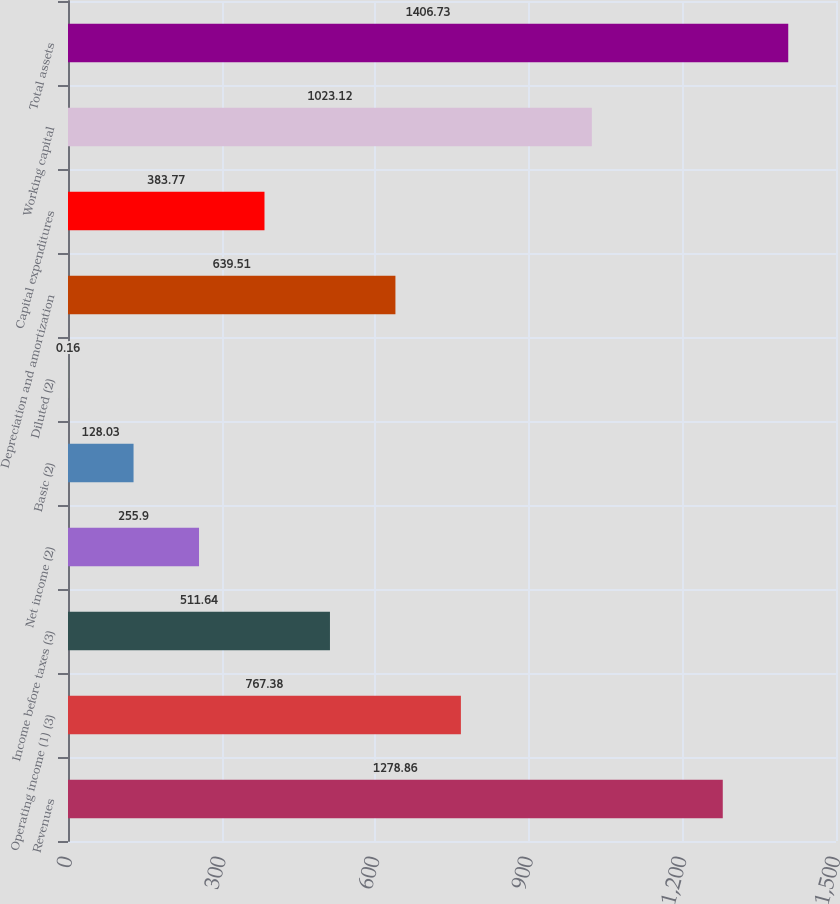Convert chart to OTSL. <chart><loc_0><loc_0><loc_500><loc_500><bar_chart><fcel>Revenues<fcel>Operating income (1) (3)<fcel>Income before taxes (3)<fcel>Net income (2)<fcel>Basic (2)<fcel>Diluted (2)<fcel>Depreciation and amortization<fcel>Capital expenditures<fcel>Working capital<fcel>Total assets<nl><fcel>1278.86<fcel>767.38<fcel>511.64<fcel>255.9<fcel>128.03<fcel>0.16<fcel>639.51<fcel>383.77<fcel>1023.12<fcel>1406.73<nl></chart> 